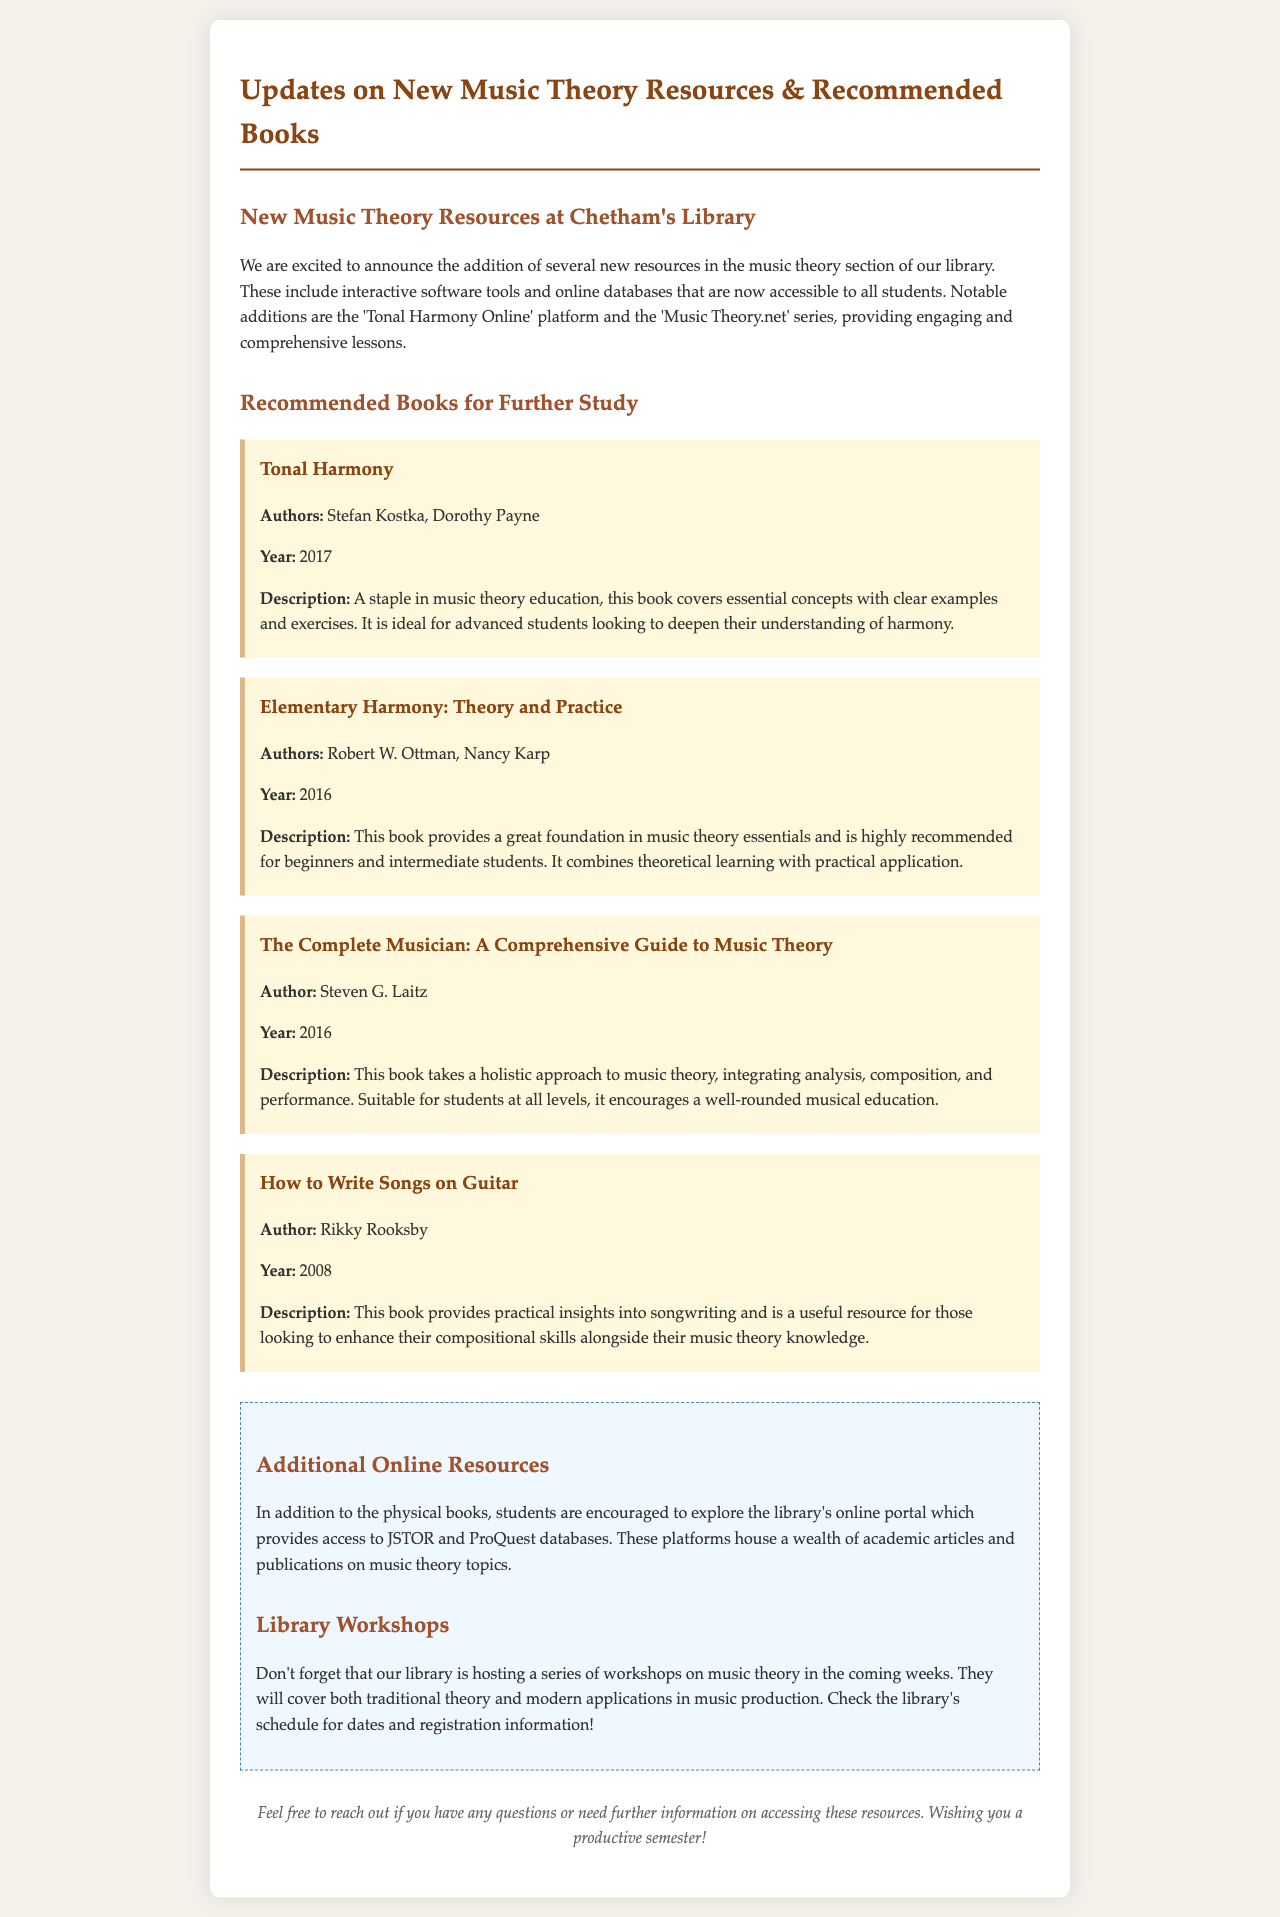what is the title of the first recommended book? The title of the first recommended book is found in the section on recommended books.
Answer: Tonal Harmony who are the authors of "Elementary Harmony: Theory and Practice"? The authors can be found in the description for that specific book.
Answer: Robert W. Ottman, Nancy Karp what year was "The Complete Musician" published? The year of publication is mentioned in the description of the book.
Answer: 2016 which online platform is mentioned for music theory resources? The specific online platforms are listed in the new music theory resources section.
Answer: Tonal Harmony Online how many workshops on music theory is the library hosting? The document mentions a series but does not specify a number of workshops.
Answer: Not specified what should students check for workshop dates? The document suggests checking something for details on the workshops.
Answer: Library's schedule what type of additional online resources are provided by the library? The type of additional resources is referred to in the additional info section.
Answer: JSTOR and ProQuest databases what kind of approach does "The Complete Musician" take? The approach of the book is described in its description section.
Answer: Holistic approach who is the author of "How to Write Songs on Guitar"? The author is provided specifically in the description for that book.
Answer: Rikky Rooksby 